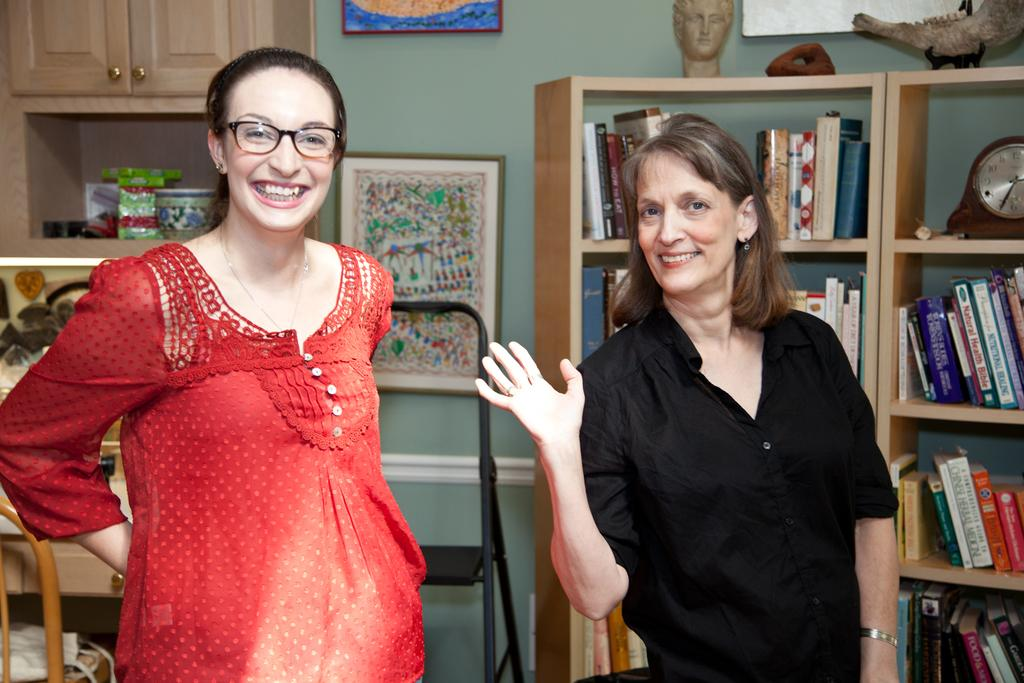What are the women in the image doing? The women in the image are standing and smiling. What can be seen in the cupboards in the image? Books are arranged in cupboards in the image. What time-telling device is present in the image? There is a clock in the image. What type of decorative elements can be seen in the image? Decor is present in the image, including wall hangings attached to the wall. What type of marble is used for the floor in the image? There is no mention of marble or a floor in the image; it only describes the women, books, clock, and decor. 